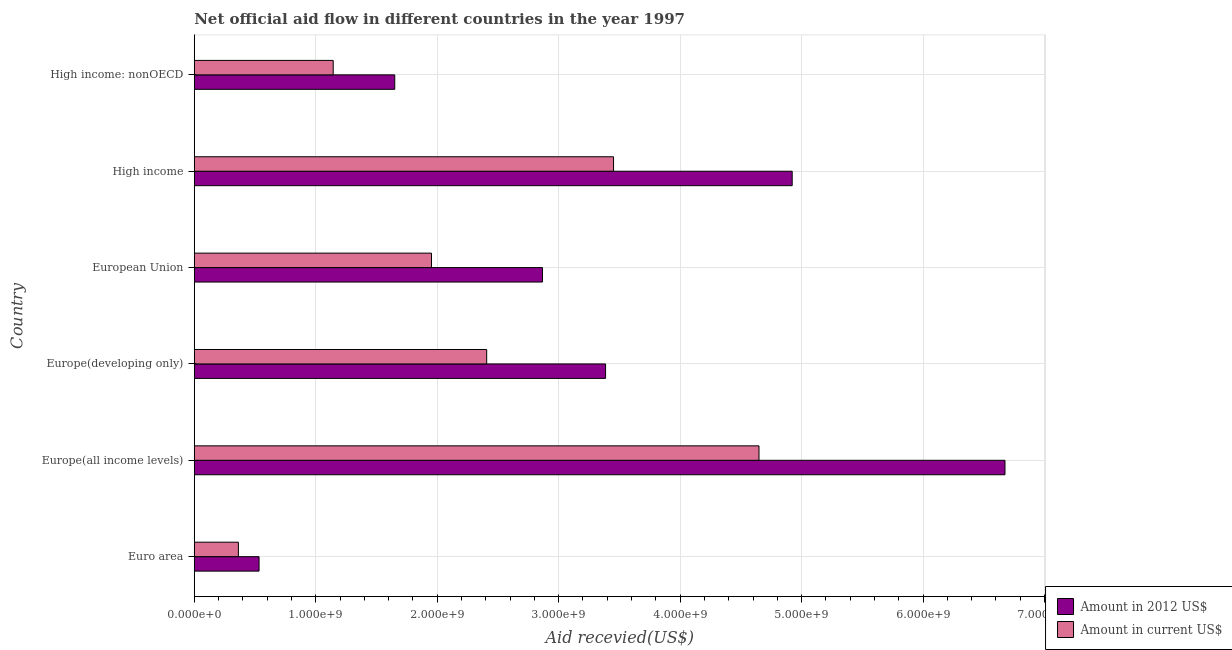How many different coloured bars are there?
Give a very brief answer. 2. How many groups of bars are there?
Your response must be concise. 6. Are the number of bars on each tick of the Y-axis equal?
Keep it short and to the point. Yes. How many bars are there on the 2nd tick from the top?
Your response must be concise. 2. How many bars are there on the 4th tick from the bottom?
Offer a terse response. 2. What is the label of the 5th group of bars from the top?
Give a very brief answer. Europe(all income levels). What is the amount of aid received(expressed in us$) in Europe(all income levels)?
Your response must be concise. 4.65e+09. Across all countries, what is the maximum amount of aid received(expressed in us$)?
Provide a short and direct response. 4.65e+09. Across all countries, what is the minimum amount of aid received(expressed in us$)?
Offer a terse response. 3.63e+08. In which country was the amount of aid received(expressed in us$) maximum?
Make the answer very short. Europe(all income levels). What is the total amount of aid received(expressed in 2012 us$) in the graph?
Provide a succinct answer. 2.00e+1. What is the difference between the amount of aid received(expressed in 2012 us$) in Euro area and that in Europe(all income levels)?
Your response must be concise. -6.14e+09. What is the difference between the amount of aid received(expressed in 2012 us$) in Euro area and the amount of aid received(expressed in us$) in European Union?
Provide a succinct answer. -1.42e+09. What is the average amount of aid received(expressed in 2012 us$) per country?
Give a very brief answer. 3.34e+09. What is the difference between the amount of aid received(expressed in us$) and amount of aid received(expressed in 2012 us$) in High income: nonOECD?
Make the answer very short. -5.07e+08. What is the ratio of the amount of aid received(expressed in us$) in Europe(developing only) to that in European Union?
Your response must be concise. 1.23. What is the difference between the highest and the second highest amount of aid received(expressed in 2012 us$)?
Ensure brevity in your answer.  1.75e+09. What is the difference between the highest and the lowest amount of aid received(expressed in 2012 us$)?
Your response must be concise. 6.14e+09. In how many countries, is the amount of aid received(expressed in us$) greater than the average amount of aid received(expressed in us$) taken over all countries?
Make the answer very short. 3. What does the 2nd bar from the top in High income: nonOECD represents?
Provide a short and direct response. Amount in 2012 US$. What does the 2nd bar from the bottom in European Union represents?
Make the answer very short. Amount in current US$. How many bars are there?
Your response must be concise. 12. What is the difference between two consecutive major ticks on the X-axis?
Your answer should be very brief. 1.00e+09. Does the graph contain any zero values?
Provide a succinct answer. No. Where does the legend appear in the graph?
Offer a terse response. Bottom right. What is the title of the graph?
Provide a succinct answer. Net official aid flow in different countries in the year 1997. What is the label or title of the X-axis?
Provide a short and direct response. Aid recevied(US$). What is the label or title of the Y-axis?
Your answer should be compact. Country. What is the Aid recevied(US$) of Amount in 2012 US$ in Euro area?
Your response must be concise. 5.33e+08. What is the Aid recevied(US$) in Amount in current US$ in Euro area?
Your response must be concise. 3.63e+08. What is the Aid recevied(US$) of Amount in 2012 US$ in Europe(all income levels)?
Offer a very short reply. 6.67e+09. What is the Aid recevied(US$) in Amount in current US$ in Europe(all income levels)?
Your answer should be compact. 4.65e+09. What is the Aid recevied(US$) of Amount in 2012 US$ in Europe(developing only)?
Provide a succinct answer. 3.39e+09. What is the Aid recevied(US$) of Amount in current US$ in Europe(developing only)?
Keep it short and to the point. 2.41e+09. What is the Aid recevied(US$) in Amount in 2012 US$ in European Union?
Your answer should be compact. 2.87e+09. What is the Aid recevied(US$) of Amount in current US$ in European Union?
Give a very brief answer. 1.95e+09. What is the Aid recevied(US$) of Amount in 2012 US$ in High income?
Your answer should be compact. 4.92e+09. What is the Aid recevied(US$) of Amount in current US$ in High income?
Keep it short and to the point. 3.45e+09. What is the Aid recevied(US$) in Amount in 2012 US$ in High income: nonOECD?
Make the answer very short. 1.65e+09. What is the Aid recevied(US$) in Amount in current US$ in High income: nonOECD?
Provide a short and direct response. 1.14e+09. Across all countries, what is the maximum Aid recevied(US$) in Amount in 2012 US$?
Your answer should be compact. 6.67e+09. Across all countries, what is the maximum Aid recevied(US$) in Amount in current US$?
Provide a succinct answer. 4.65e+09. Across all countries, what is the minimum Aid recevied(US$) in Amount in 2012 US$?
Your response must be concise. 5.33e+08. Across all countries, what is the minimum Aid recevied(US$) of Amount in current US$?
Keep it short and to the point. 3.63e+08. What is the total Aid recevied(US$) in Amount in 2012 US$ in the graph?
Offer a very short reply. 2.00e+1. What is the total Aid recevied(US$) in Amount in current US$ in the graph?
Your answer should be compact. 1.40e+1. What is the difference between the Aid recevied(US$) in Amount in 2012 US$ in Euro area and that in Europe(all income levels)?
Offer a terse response. -6.14e+09. What is the difference between the Aid recevied(US$) in Amount in current US$ in Euro area and that in Europe(all income levels)?
Provide a succinct answer. -4.29e+09. What is the difference between the Aid recevied(US$) of Amount in 2012 US$ in Euro area and that in Europe(developing only)?
Your answer should be compact. -2.85e+09. What is the difference between the Aid recevied(US$) in Amount in current US$ in Euro area and that in Europe(developing only)?
Your answer should be compact. -2.04e+09. What is the difference between the Aid recevied(US$) in Amount in 2012 US$ in Euro area and that in European Union?
Keep it short and to the point. -2.33e+09. What is the difference between the Aid recevied(US$) in Amount in current US$ in Euro area and that in European Union?
Your answer should be very brief. -1.59e+09. What is the difference between the Aid recevied(US$) in Amount in 2012 US$ in Euro area and that in High income?
Ensure brevity in your answer.  -4.39e+09. What is the difference between the Aid recevied(US$) of Amount in current US$ in Euro area and that in High income?
Offer a terse response. -3.09e+09. What is the difference between the Aid recevied(US$) in Amount in 2012 US$ in Euro area and that in High income: nonOECD?
Provide a succinct answer. -1.12e+09. What is the difference between the Aid recevied(US$) of Amount in current US$ in Euro area and that in High income: nonOECD?
Your response must be concise. -7.80e+08. What is the difference between the Aid recevied(US$) in Amount in 2012 US$ in Europe(all income levels) and that in Europe(developing only)?
Your answer should be very brief. 3.29e+09. What is the difference between the Aid recevied(US$) of Amount in current US$ in Europe(all income levels) and that in Europe(developing only)?
Provide a succinct answer. 2.24e+09. What is the difference between the Aid recevied(US$) in Amount in 2012 US$ in Europe(all income levels) and that in European Union?
Your answer should be very brief. 3.81e+09. What is the difference between the Aid recevied(US$) in Amount in current US$ in Europe(all income levels) and that in European Union?
Ensure brevity in your answer.  2.70e+09. What is the difference between the Aid recevied(US$) of Amount in 2012 US$ in Europe(all income levels) and that in High income?
Your response must be concise. 1.75e+09. What is the difference between the Aid recevied(US$) of Amount in current US$ in Europe(all income levels) and that in High income?
Provide a succinct answer. 1.20e+09. What is the difference between the Aid recevied(US$) of Amount in 2012 US$ in Europe(all income levels) and that in High income: nonOECD?
Give a very brief answer. 5.02e+09. What is the difference between the Aid recevied(US$) of Amount in current US$ in Europe(all income levels) and that in High income: nonOECD?
Your answer should be very brief. 3.51e+09. What is the difference between the Aid recevied(US$) in Amount in 2012 US$ in Europe(developing only) and that in European Union?
Offer a very short reply. 5.19e+08. What is the difference between the Aid recevied(US$) in Amount in current US$ in Europe(developing only) and that in European Union?
Provide a succinct answer. 4.54e+08. What is the difference between the Aid recevied(US$) of Amount in 2012 US$ in Europe(developing only) and that in High income?
Keep it short and to the point. -1.54e+09. What is the difference between the Aid recevied(US$) of Amount in current US$ in Europe(developing only) and that in High income?
Your response must be concise. -1.04e+09. What is the difference between the Aid recevied(US$) of Amount in 2012 US$ in Europe(developing only) and that in High income: nonOECD?
Ensure brevity in your answer.  1.74e+09. What is the difference between the Aid recevied(US$) of Amount in current US$ in Europe(developing only) and that in High income: nonOECD?
Make the answer very short. 1.26e+09. What is the difference between the Aid recevied(US$) in Amount in 2012 US$ in European Union and that in High income?
Your answer should be compact. -2.06e+09. What is the difference between the Aid recevied(US$) of Amount in current US$ in European Union and that in High income?
Your answer should be very brief. -1.50e+09. What is the difference between the Aid recevied(US$) in Amount in 2012 US$ in European Union and that in High income: nonOECD?
Your answer should be compact. 1.22e+09. What is the difference between the Aid recevied(US$) of Amount in current US$ in European Union and that in High income: nonOECD?
Give a very brief answer. 8.09e+08. What is the difference between the Aid recevied(US$) of Amount in 2012 US$ in High income and that in High income: nonOECD?
Offer a terse response. 3.27e+09. What is the difference between the Aid recevied(US$) in Amount in current US$ in High income and that in High income: nonOECD?
Keep it short and to the point. 2.31e+09. What is the difference between the Aid recevied(US$) in Amount in 2012 US$ in Euro area and the Aid recevied(US$) in Amount in current US$ in Europe(all income levels)?
Offer a terse response. -4.12e+09. What is the difference between the Aid recevied(US$) of Amount in 2012 US$ in Euro area and the Aid recevied(US$) of Amount in current US$ in Europe(developing only)?
Give a very brief answer. -1.87e+09. What is the difference between the Aid recevied(US$) of Amount in 2012 US$ in Euro area and the Aid recevied(US$) of Amount in current US$ in European Union?
Provide a short and direct response. -1.42e+09. What is the difference between the Aid recevied(US$) of Amount in 2012 US$ in Euro area and the Aid recevied(US$) of Amount in current US$ in High income?
Offer a very short reply. -2.92e+09. What is the difference between the Aid recevied(US$) of Amount in 2012 US$ in Euro area and the Aid recevied(US$) of Amount in current US$ in High income: nonOECD?
Ensure brevity in your answer.  -6.10e+08. What is the difference between the Aid recevied(US$) of Amount in 2012 US$ in Europe(all income levels) and the Aid recevied(US$) of Amount in current US$ in Europe(developing only)?
Your response must be concise. 4.27e+09. What is the difference between the Aid recevied(US$) in Amount in 2012 US$ in Europe(all income levels) and the Aid recevied(US$) in Amount in current US$ in European Union?
Keep it short and to the point. 4.72e+09. What is the difference between the Aid recevied(US$) in Amount in 2012 US$ in Europe(all income levels) and the Aid recevied(US$) in Amount in current US$ in High income?
Offer a terse response. 3.22e+09. What is the difference between the Aid recevied(US$) of Amount in 2012 US$ in Europe(all income levels) and the Aid recevied(US$) of Amount in current US$ in High income: nonOECD?
Provide a succinct answer. 5.53e+09. What is the difference between the Aid recevied(US$) of Amount in 2012 US$ in Europe(developing only) and the Aid recevied(US$) of Amount in current US$ in European Union?
Provide a succinct answer. 1.43e+09. What is the difference between the Aid recevied(US$) in Amount in 2012 US$ in Europe(developing only) and the Aid recevied(US$) in Amount in current US$ in High income?
Your response must be concise. -6.56e+07. What is the difference between the Aid recevied(US$) in Amount in 2012 US$ in Europe(developing only) and the Aid recevied(US$) in Amount in current US$ in High income: nonOECD?
Provide a short and direct response. 2.24e+09. What is the difference between the Aid recevied(US$) in Amount in 2012 US$ in European Union and the Aid recevied(US$) in Amount in current US$ in High income?
Keep it short and to the point. -5.85e+08. What is the difference between the Aid recevied(US$) of Amount in 2012 US$ in European Union and the Aid recevied(US$) of Amount in current US$ in High income: nonOECD?
Ensure brevity in your answer.  1.72e+09. What is the difference between the Aid recevied(US$) in Amount in 2012 US$ in High income and the Aid recevied(US$) in Amount in current US$ in High income: nonOECD?
Offer a terse response. 3.78e+09. What is the average Aid recevied(US$) in Amount in 2012 US$ per country?
Offer a very short reply. 3.34e+09. What is the average Aid recevied(US$) in Amount in current US$ per country?
Ensure brevity in your answer.  2.33e+09. What is the difference between the Aid recevied(US$) in Amount in 2012 US$ and Aid recevied(US$) in Amount in current US$ in Euro area?
Offer a terse response. 1.70e+08. What is the difference between the Aid recevied(US$) in Amount in 2012 US$ and Aid recevied(US$) in Amount in current US$ in Europe(all income levels)?
Provide a short and direct response. 2.03e+09. What is the difference between the Aid recevied(US$) in Amount in 2012 US$ and Aid recevied(US$) in Amount in current US$ in Europe(developing only)?
Your answer should be very brief. 9.79e+08. What is the difference between the Aid recevied(US$) of Amount in 2012 US$ and Aid recevied(US$) of Amount in current US$ in European Union?
Your answer should be very brief. 9.14e+08. What is the difference between the Aid recevied(US$) of Amount in 2012 US$ and Aid recevied(US$) of Amount in current US$ in High income?
Offer a very short reply. 1.47e+09. What is the difference between the Aid recevied(US$) in Amount in 2012 US$ and Aid recevied(US$) in Amount in current US$ in High income: nonOECD?
Your answer should be very brief. 5.07e+08. What is the ratio of the Aid recevied(US$) of Amount in 2012 US$ in Euro area to that in Europe(all income levels)?
Provide a succinct answer. 0.08. What is the ratio of the Aid recevied(US$) of Amount in current US$ in Euro area to that in Europe(all income levels)?
Give a very brief answer. 0.08. What is the ratio of the Aid recevied(US$) in Amount in 2012 US$ in Euro area to that in Europe(developing only)?
Give a very brief answer. 0.16. What is the ratio of the Aid recevied(US$) in Amount in current US$ in Euro area to that in Europe(developing only)?
Provide a short and direct response. 0.15. What is the ratio of the Aid recevied(US$) in Amount in 2012 US$ in Euro area to that in European Union?
Give a very brief answer. 0.19. What is the ratio of the Aid recevied(US$) of Amount in current US$ in Euro area to that in European Union?
Keep it short and to the point. 0.19. What is the ratio of the Aid recevied(US$) in Amount in 2012 US$ in Euro area to that in High income?
Your answer should be very brief. 0.11. What is the ratio of the Aid recevied(US$) of Amount in current US$ in Euro area to that in High income?
Your response must be concise. 0.11. What is the ratio of the Aid recevied(US$) of Amount in 2012 US$ in Euro area to that in High income: nonOECD?
Provide a succinct answer. 0.32. What is the ratio of the Aid recevied(US$) in Amount in current US$ in Euro area to that in High income: nonOECD?
Ensure brevity in your answer.  0.32. What is the ratio of the Aid recevied(US$) of Amount in 2012 US$ in Europe(all income levels) to that in Europe(developing only)?
Give a very brief answer. 1.97. What is the ratio of the Aid recevied(US$) of Amount in current US$ in Europe(all income levels) to that in Europe(developing only)?
Offer a terse response. 1.93. What is the ratio of the Aid recevied(US$) in Amount in 2012 US$ in Europe(all income levels) to that in European Union?
Your answer should be very brief. 2.33. What is the ratio of the Aid recevied(US$) of Amount in current US$ in Europe(all income levels) to that in European Union?
Offer a very short reply. 2.38. What is the ratio of the Aid recevied(US$) of Amount in 2012 US$ in Europe(all income levels) to that in High income?
Make the answer very short. 1.36. What is the ratio of the Aid recevied(US$) of Amount in current US$ in Europe(all income levels) to that in High income?
Your answer should be compact. 1.35. What is the ratio of the Aid recevied(US$) in Amount in 2012 US$ in Europe(all income levels) to that in High income: nonOECD?
Give a very brief answer. 4.04. What is the ratio of the Aid recevied(US$) in Amount in current US$ in Europe(all income levels) to that in High income: nonOECD?
Your response must be concise. 4.06. What is the ratio of the Aid recevied(US$) in Amount in 2012 US$ in Europe(developing only) to that in European Union?
Keep it short and to the point. 1.18. What is the ratio of the Aid recevied(US$) in Amount in current US$ in Europe(developing only) to that in European Union?
Offer a terse response. 1.23. What is the ratio of the Aid recevied(US$) of Amount in 2012 US$ in Europe(developing only) to that in High income?
Ensure brevity in your answer.  0.69. What is the ratio of the Aid recevied(US$) in Amount in current US$ in Europe(developing only) to that in High income?
Your response must be concise. 0.7. What is the ratio of the Aid recevied(US$) of Amount in 2012 US$ in Europe(developing only) to that in High income: nonOECD?
Offer a terse response. 2.05. What is the ratio of the Aid recevied(US$) of Amount in current US$ in Europe(developing only) to that in High income: nonOECD?
Keep it short and to the point. 2.1. What is the ratio of the Aid recevied(US$) of Amount in 2012 US$ in European Union to that in High income?
Ensure brevity in your answer.  0.58. What is the ratio of the Aid recevied(US$) in Amount in current US$ in European Union to that in High income?
Keep it short and to the point. 0.57. What is the ratio of the Aid recevied(US$) in Amount in 2012 US$ in European Union to that in High income: nonOECD?
Your answer should be compact. 1.74. What is the ratio of the Aid recevied(US$) in Amount in current US$ in European Union to that in High income: nonOECD?
Keep it short and to the point. 1.71. What is the ratio of the Aid recevied(US$) of Amount in 2012 US$ in High income to that in High income: nonOECD?
Your answer should be compact. 2.98. What is the ratio of the Aid recevied(US$) in Amount in current US$ in High income to that in High income: nonOECD?
Provide a succinct answer. 3.02. What is the difference between the highest and the second highest Aid recevied(US$) in Amount in 2012 US$?
Your response must be concise. 1.75e+09. What is the difference between the highest and the second highest Aid recevied(US$) of Amount in current US$?
Your response must be concise. 1.20e+09. What is the difference between the highest and the lowest Aid recevied(US$) in Amount in 2012 US$?
Provide a succinct answer. 6.14e+09. What is the difference between the highest and the lowest Aid recevied(US$) in Amount in current US$?
Offer a very short reply. 4.29e+09. 